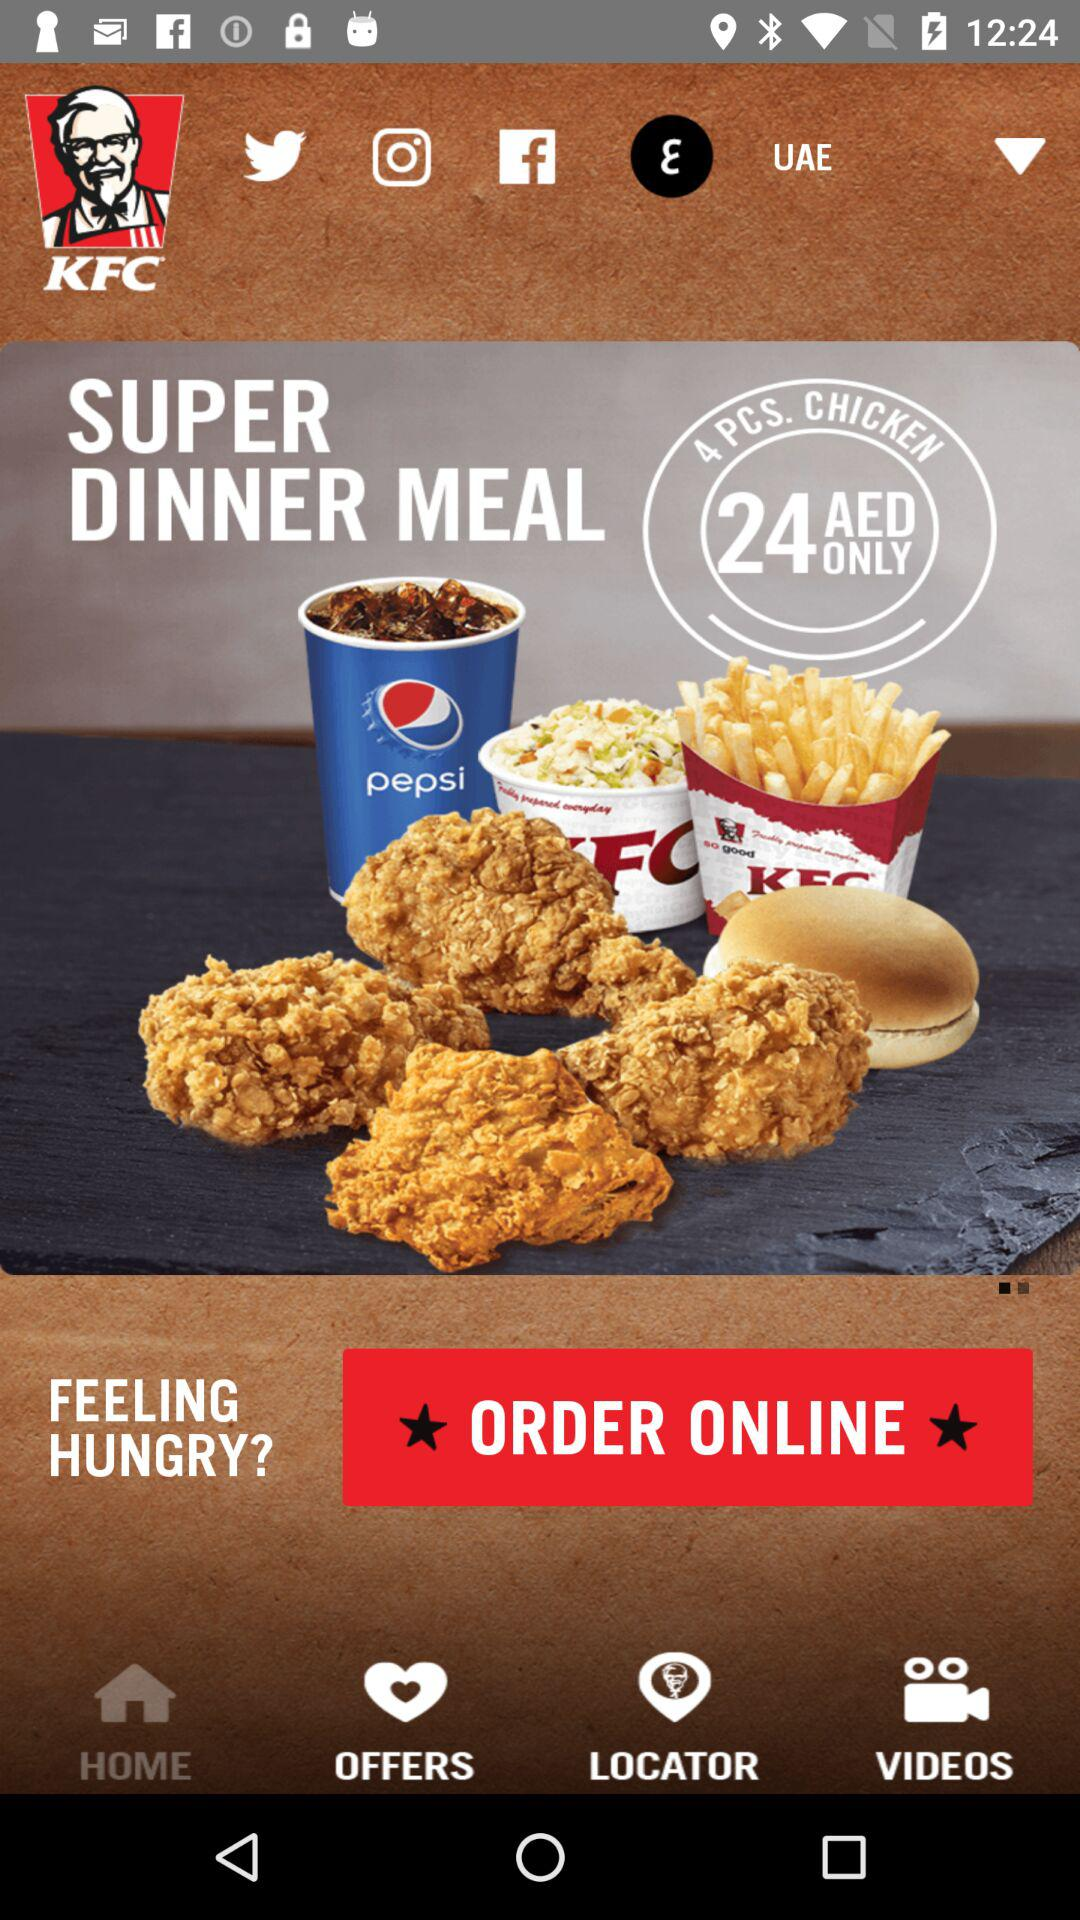What is the currency of price? The currency of price is "AED". 